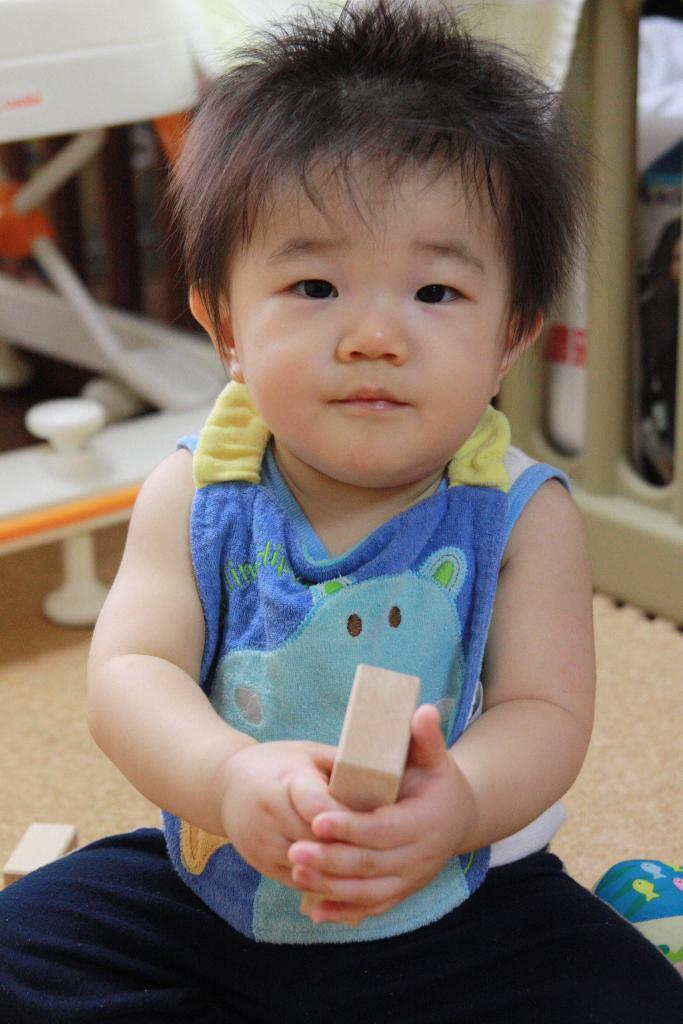What is the main subject of the image? There is a baby in the image. What is the baby wearing? The baby is wearing a blue vest and black pants. Where is the baby located in the image? The baby is sitting on the floor. What is the baby holding in the image? The baby is holding a wooden block. What can be seen behind the baby in the image? There is a baby cradle visible behind the baby. What type of unit is the baby fighting against in the image? There is no indication of a fight or any units in the image; it simply shows a baby sitting on the floor holding a wooden block. 